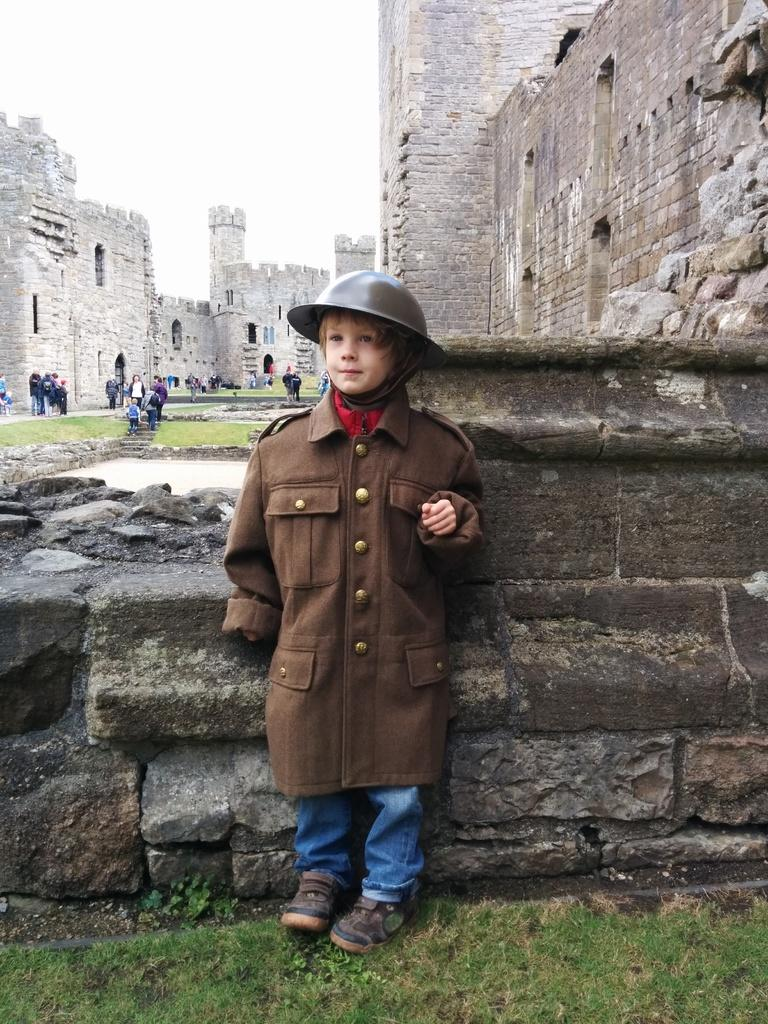Who is the main subject in the image? There is a boy in the image. What is the boy doing in the image? The boy is standing. What is the boy wearing on his head? The boy is wearing a cap. What can be seen in the background of the image? There is a fort and people in the background of the image. What type of ground is visible in the image? There is grass on the ground in the image. How would you describe the sky in the image? The sky is cloudy in the image. What type of watch is the boy wearing in the image? There is no watch visible in the image; the boy is wearing a cap. How many pizzas can be seen in the image? There are no pizzas present in the image. 